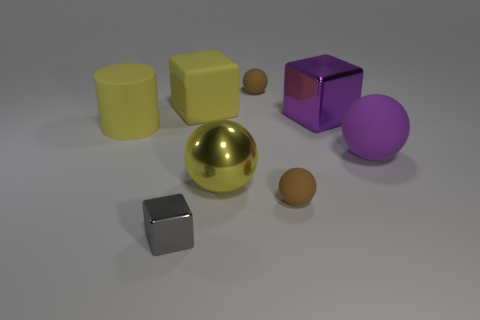Do the yellow metallic thing and the cylinder have the same size?
Give a very brief answer. Yes. How many cubes have the same size as the matte cylinder?
Your response must be concise. 2. Is the tiny gray object made of the same material as the small brown object that is in front of the yellow shiny ball?
Give a very brief answer. No. Is the number of big purple rubber spheres less than the number of small cyan shiny spheres?
Your answer should be very brief. No. Is there any other thing that has the same color as the small cube?
Give a very brief answer. No. There is a yellow object that is made of the same material as the gray thing; what shape is it?
Your response must be concise. Sphere. How many matte objects are right of the tiny thing behind the yellow thing that is left of the gray block?
Offer a terse response. 2. What is the shape of the small object that is in front of the yellow shiny ball and behind the tiny gray metallic object?
Your response must be concise. Sphere. Is the number of small things on the left side of the big yellow metal object less than the number of brown matte objects?
Offer a terse response. Yes. How many big objects are either purple matte spheres or cyan rubber cylinders?
Keep it short and to the point. 1. 